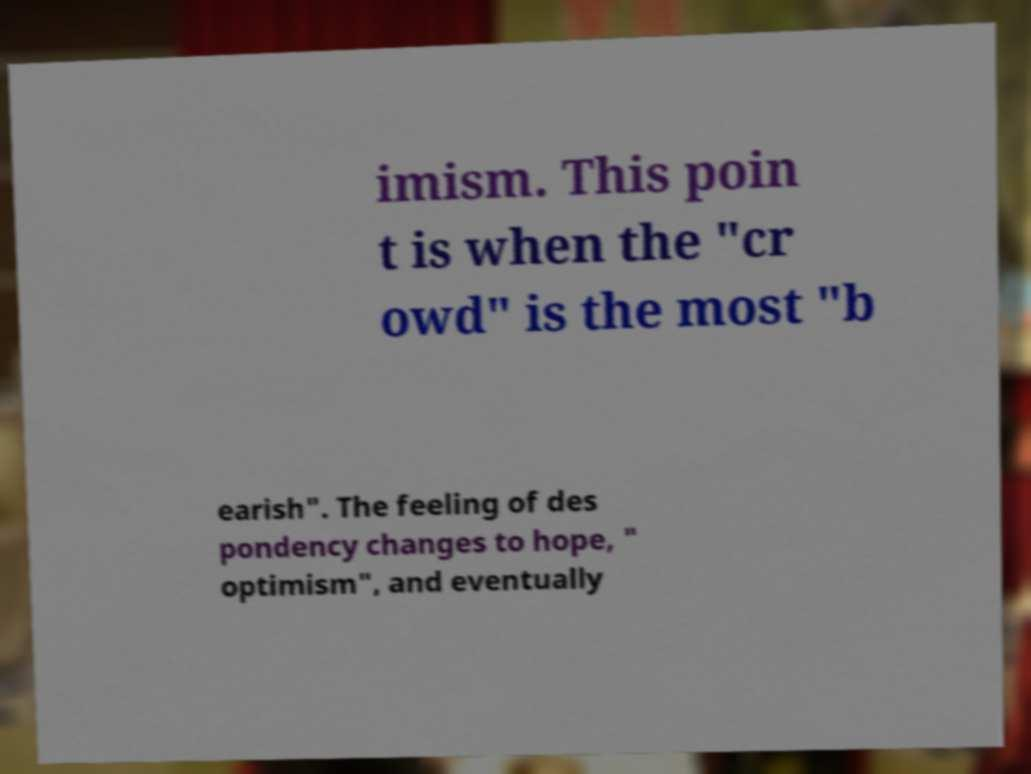Could you assist in decoding the text presented in this image and type it out clearly? imism. This poin t is when the "cr owd" is the most "b earish". The feeling of des pondency changes to hope, " optimism", and eventually 